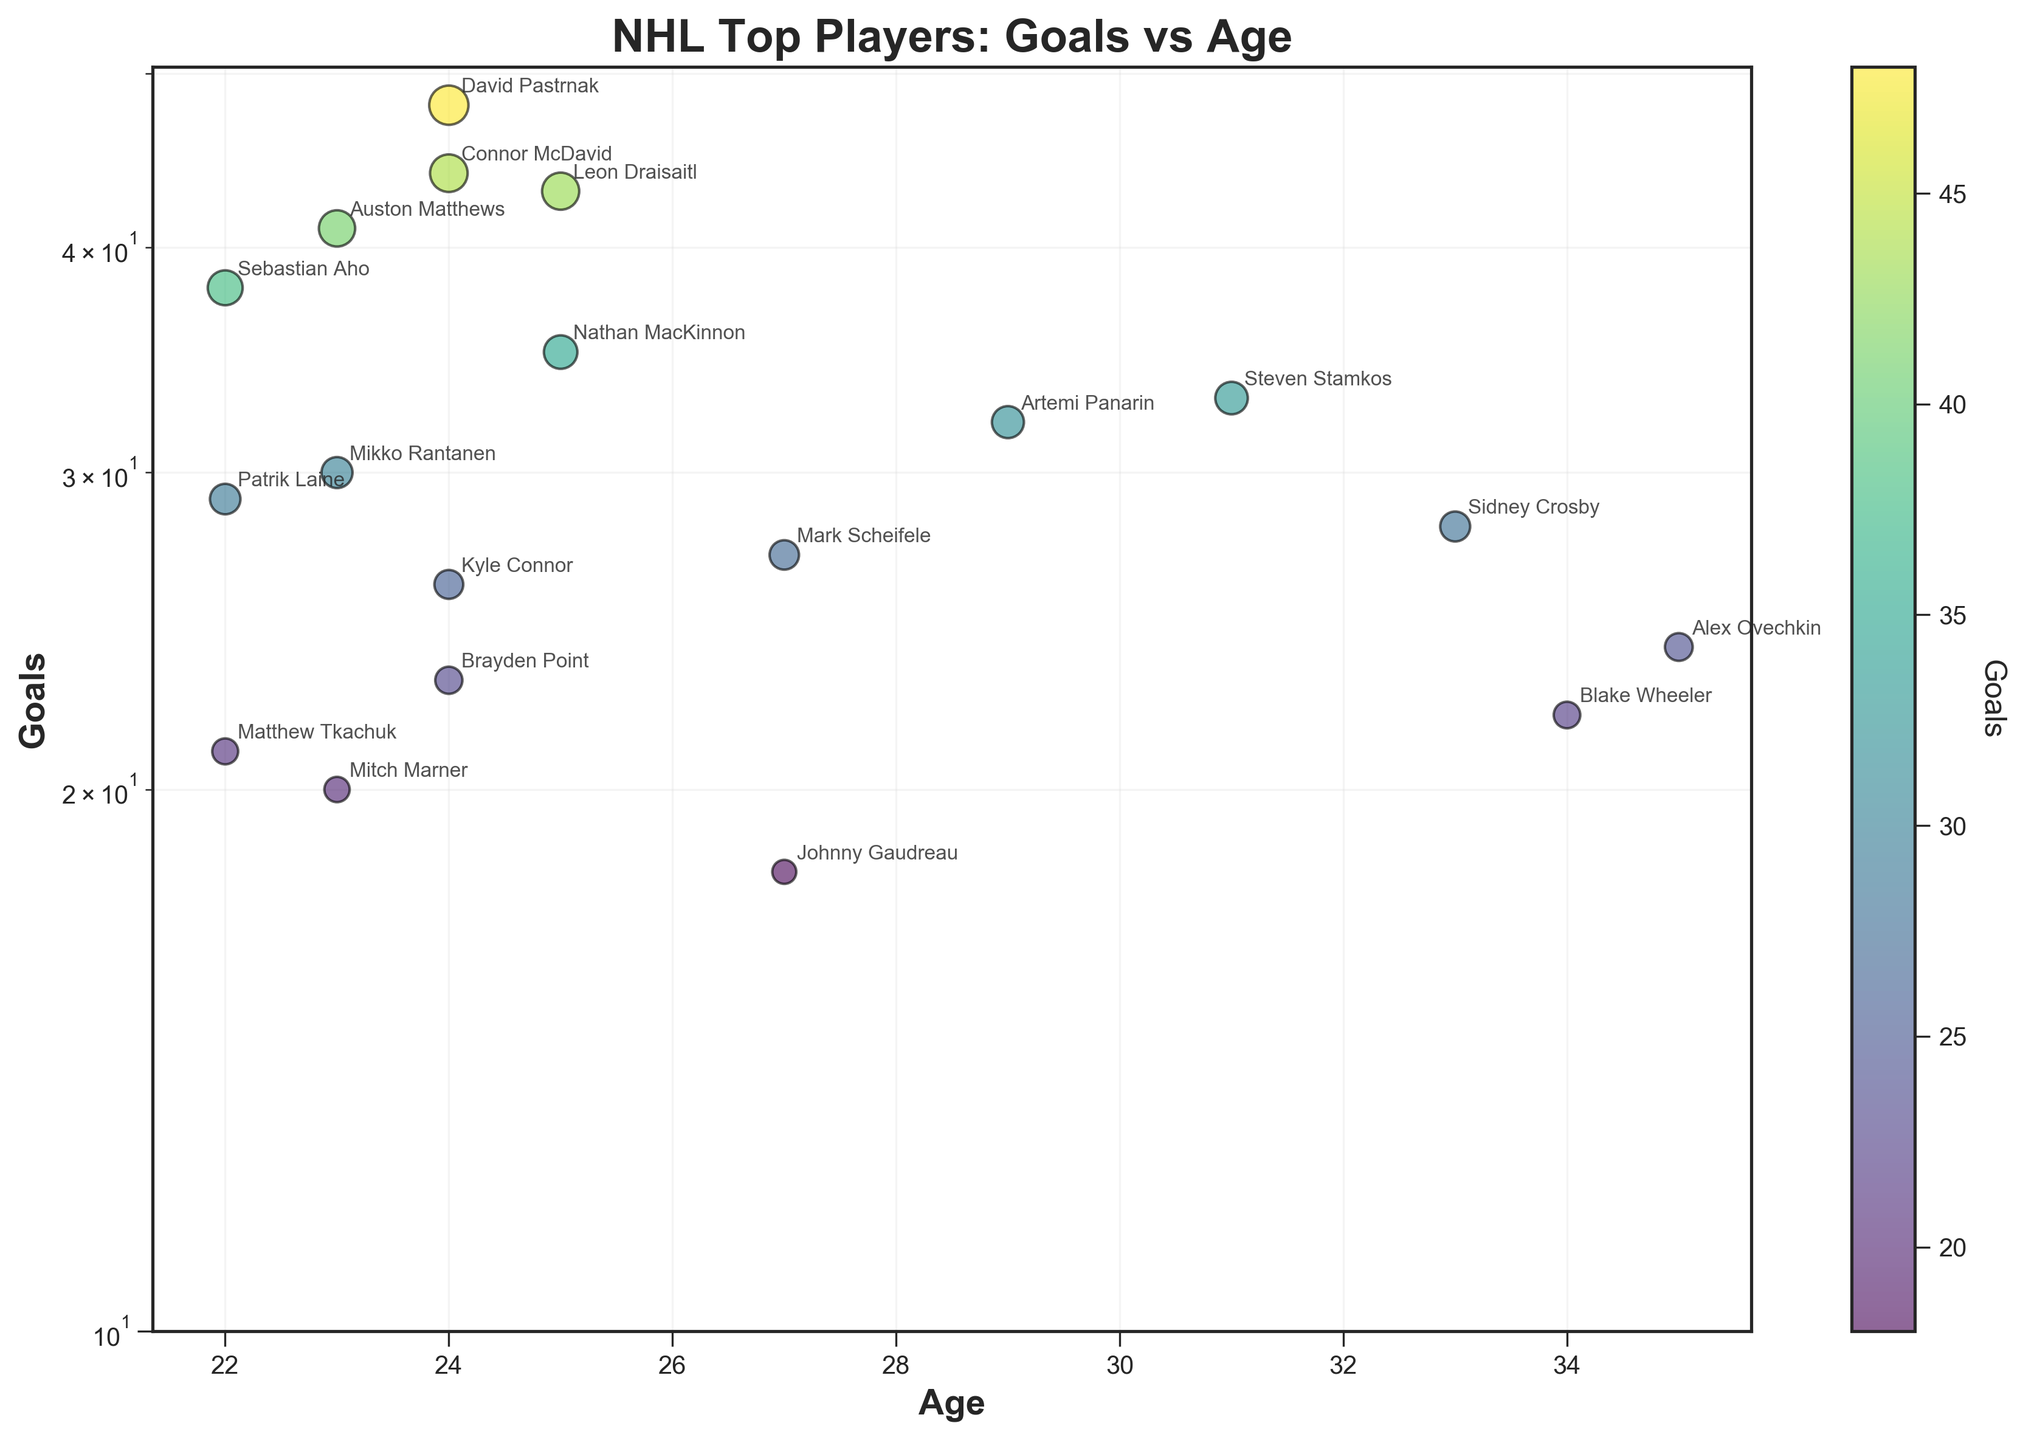How many players are aged 25? To find this, look at the x-axis for age 25 and count the corresponding data points. There are three players aged 25 (Leon Draisaitl, Nathan MacKinnon, and David Pastrnak).
Answer: 3 Which player scored the most goals? Check the y-axis for the player with the highest position. David Pastrnak, with 48 goals, is the top scorer.
Answer: David Pastrnak What is the relationship between age and goals scored among the top players? Observe the trend of data points. While most top scorers are younger, there are exceptions like Alex Ovechkin. No clear single correlation, but younger players tend to have higher goals except for veterans like Ovechkin.
Answer: Younger players often score more goals, with exceptions Compare goals scored by Auston Matthews and Patrik Laine. Who has more? Check the y-axis values for Auston Matthews and Patrik Laine. Matthews has 41 goals, while Laine has 29 goals.
Answer: Auston Matthews What is the sum of goals scored by Mark Scheifele and Kyle Connor? Find the goals scored by Scheifele (27) and Connor (26) on the y-axis, then add them together. 27 + 26 = 53.
Answer: 53 Who is the oldest player and how many goals has he scored? Identify the player with the highest age on the x-axis (Alex Ovechkin, 35) and check his goal count (24).
Answer: Alex Ovechkin, 24 goals Which Winnipeg Jets players are included in the chart? Look for the players with “Winnipeg Jets” annotations next to their points. Mark Scheifele, Kyle Connor, and Blake Wheeler are the Jets included.
Answer: Mark Scheifele, Kyle Connor, Blake Wheeler Are there any players aged 22, and how many goals do they have on average? Find all players aged 22 (Patrik Laine, Sebastian Aho, Matthew Tkachuk), sum their goals (29, 38, 21), divide by the number of players. (29 + 38 + 21) / 3 = 29.33.
Answer: 29.33 Which player over 30 years old scored the most goals? Identify players older than 30 (Steven Stamkos, Alex Ovechkin, Blake Wheeler) and compare their goals. Steven Stamkos scored the most with 33 goals.
Answer: Steven Stamkos 